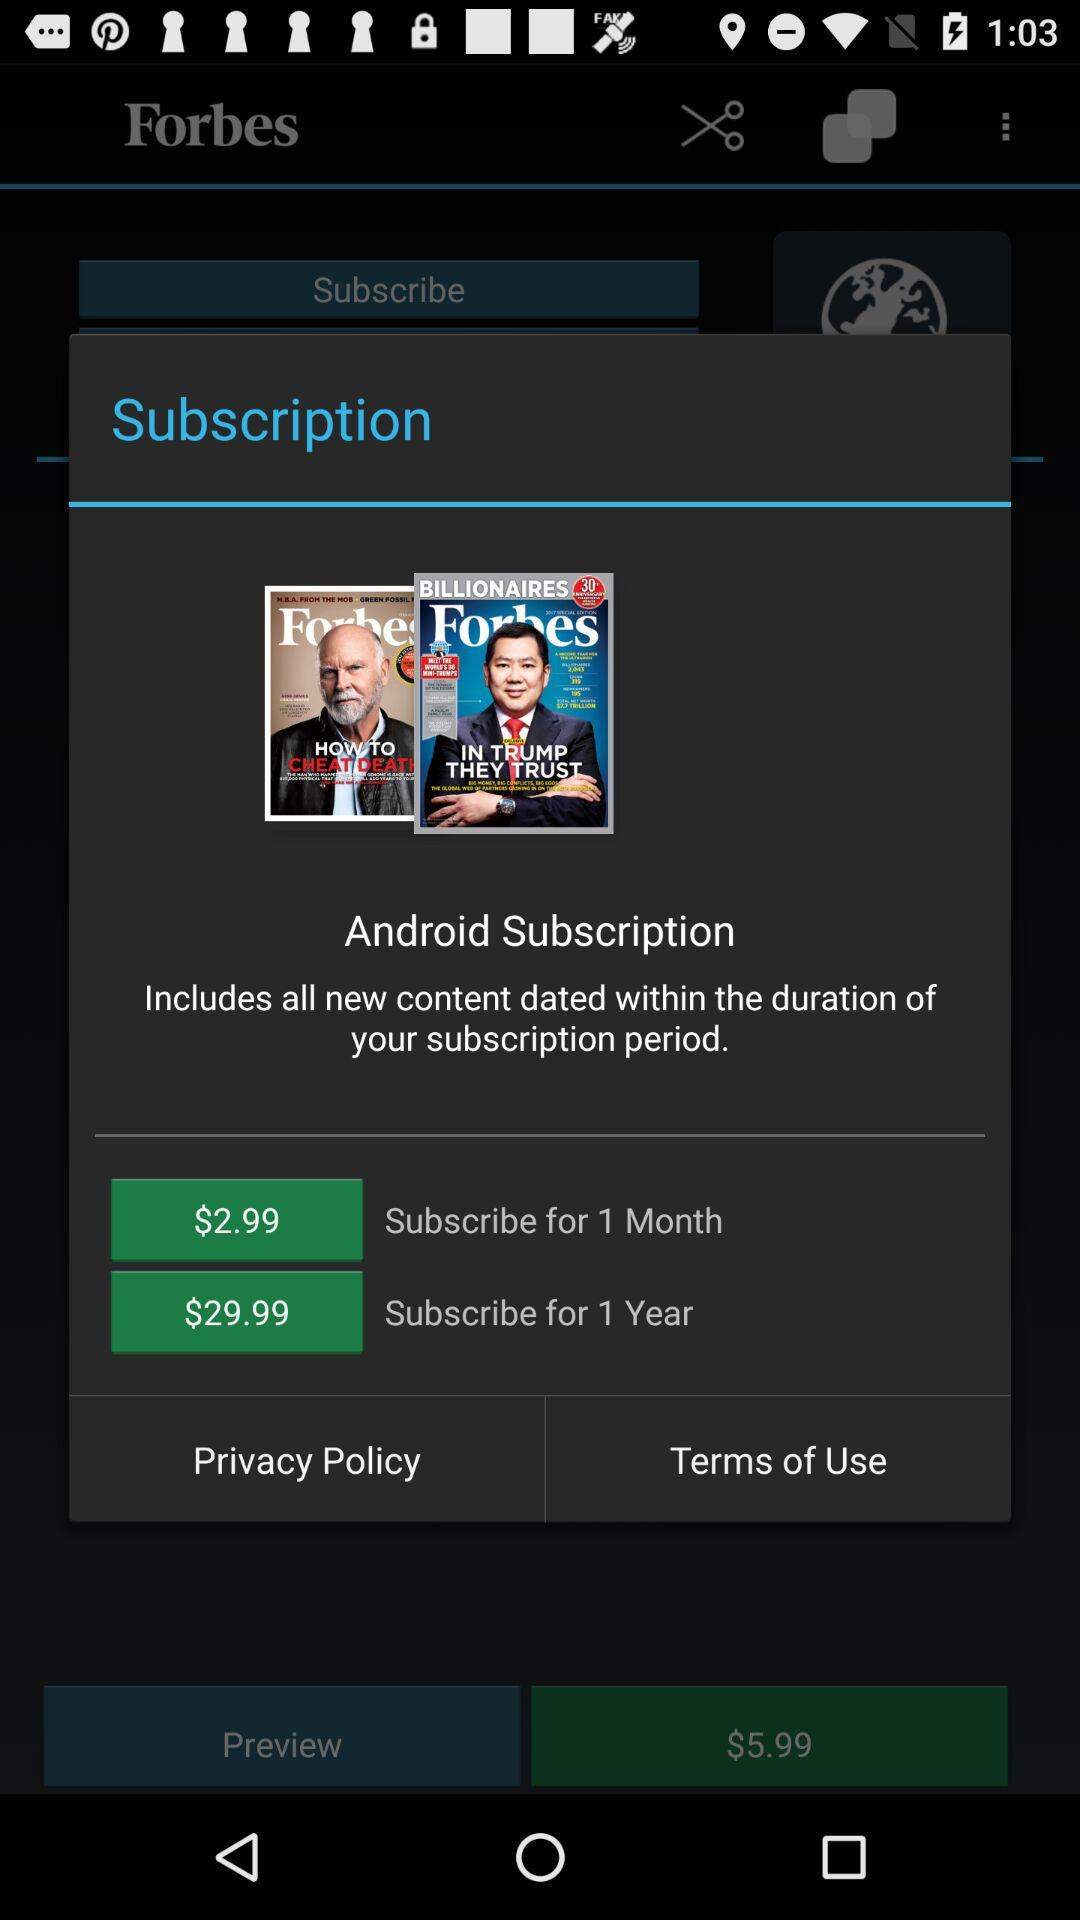How many more dollars does the 1 year subscription cost than the 1 month subscription?
Answer the question using a single word or phrase. 27 